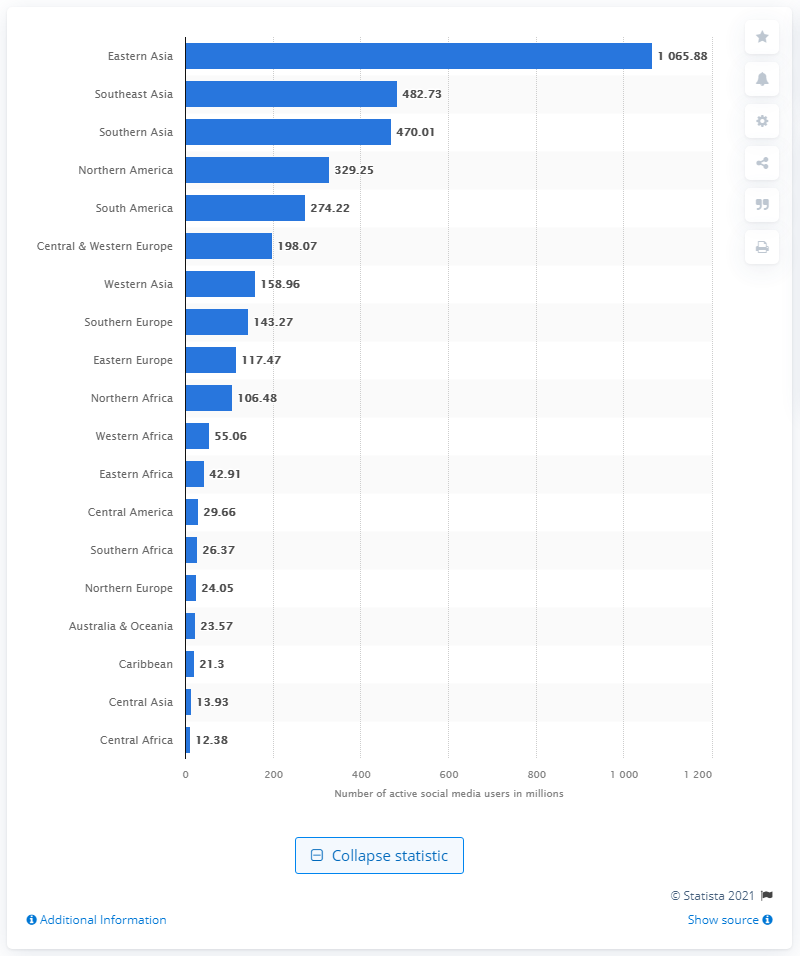List a handful of essential elements in this visual. In 2020, there were approximately 1065.88 million social media users in Eastern Asia. 